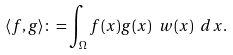Convert formula to latex. <formula><loc_0><loc_0><loc_500><loc_500>\langle f , g \rangle \colon = \int _ { \Omega } f ( x ) g ( x ) \ w ( x ) \ d x .</formula> 